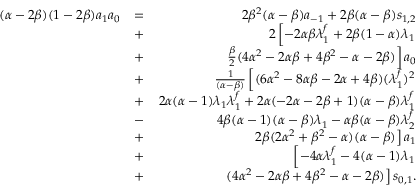<formula> <loc_0><loc_0><loc_500><loc_500>\begin{array} { r l r } { ( \alpha - 2 \beta ) ( 1 - 2 \beta ) a _ { 1 } a _ { 0 } } & { = } & { 2 \beta ^ { 2 } ( \alpha - \beta ) a _ { - 1 } + 2 \beta ( \alpha - \beta ) s _ { 1 , 2 } } \\ & { + } & { 2 \left [ - 2 \alpha \beta \lambda _ { 1 } ^ { f } + 2 \beta ( 1 - \alpha ) \lambda _ { 1 } } \\ & { + } & { \frac { \beta } { 2 } ( 4 \alpha ^ { 2 } - 2 \alpha \beta + 4 \beta ^ { 2 } - \alpha - 2 \beta ) \right ] a _ { 0 } } \\ & { + } & { \frac { 1 } { ( \alpha - \beta ) } \left [ ( 6 \alpha ^ { 2 } - 8 \alpha \beta - 2 \alpha + 4 \beta ) ( \lambda _ { 1 } ^ { f } ) ^ { 2 } } \\ & { + } & { 2 \alpha ( \alpha - 1 ) \lambda _ { 1 } \lambda _ { 1 } ^ { f } + 2 \alpha ( - 2 \alpha - 2 \beta + 1 ) ( \alpha - \beta ) \lambda _ { 1 } ^ { f } } \\ & { - } & { 4 \beta ( \alpha - 1 ) ( \alpha - \beta ) \lambda _ { 1 } - \alpha \beta ( \alpha - \beta ) \lambda _ { 2 } ^ { f } } \\ & { + } & { 2 \beta ( 2 \alpha ^ { 2 } + \beta ^ { 2 } - \alpha ) ( \alpha - \beta ) \right ] a _ { 1 } } \\ & { + } & { \left [ - 4 \alpha \lambda _ { 1 } ^ { f } - 4 ( \alpha - 1 ) \lambda _ { 1 } } \\ & { + } & { ( 4 \alpha ^ { 2 } - 2 \alpha \beta + 4 \beta ^ { 2 } - \alpha - 2 \beta ) \right ] s _ { 0 , 1 } . } \end{array}</formula> 